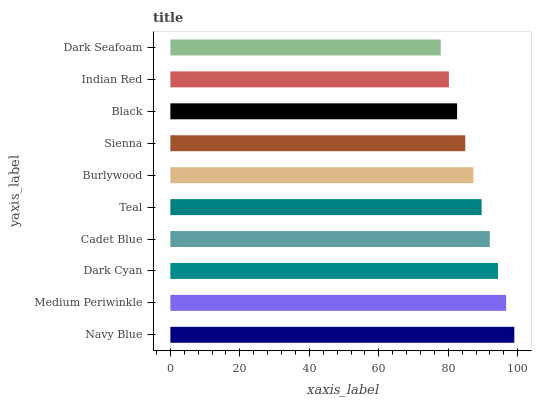Is Dark Seafoam the minimum?
Answer yes or no. Yes. Is Navy Blue the maximum?
Answer yes or no. Yes. Is Medium Periwinkle the minimum?
Answer yes or no. No. Is Medium Periwinkle the maximum?
Answer yes or no. No. Is Navy Blue greater than Medium Periwinkle?
Answer yes or no. Yes. Is Medium Periwinkle less than Navy Blue?
Answer yes or no. Yes. Is Medium Periwinkle greater than Navy Blue?
Answer yes or no. No. Is Navy Blue less than Medium Periwinkle?
Answer yes or no. No. Is Teal the high median?
Answer yes or no. Yes. Is Burlywood the low median?
Answer yes or no. Yes. Is Indian Red the high median?
Answer yes or no. No. Is Dark Seafoam the low median?
Answer yes or no. No. 